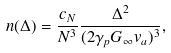Convert formula to latex. <formula><loc_0><loc_0><loc_500><loc_500>n ( \Delta ) = \frac { c _ { N } } { N ^ { 3 } } \frac { \Delta ^ { 2 } } { ( 2 \gamma _ { p } G _ { \infty } v _ { a } ) ^ { 3 } } ,</formula> 